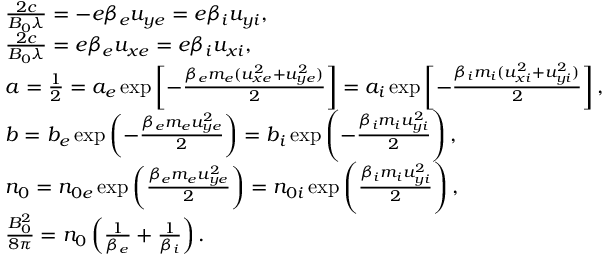Convert formula to latex. <formula><loc_0><loc_0><loc_500><loc_500>\begin{array} { r l } & { \frac { 2 c } { B _ { 0 } \lambda } = - e \beta _ { e } u _ { y e } = e \beta _ { i } u _ { y i } , } \\ & { \frac { 2 c } { B _ { 0 } \lambda } = e \beta _ { e } u _ { x e } = e \beta _ { i } u _ { x i } , } \\ & { a = \frac { 1 } { 2 } = a _ { e } \exp \left [ - \frac { \beta _ { e } m _ { e } ( u _ { x e } ^ { 2 } + u _ { y e } ^ { 2 } ) } { 2 } \right ] = a _ { i } \exp \left [ - \frac { \beta _ { i } m _ { i } ( u _ { x i } ^ { 2 } + u _ { y i } ^ { 2 } ) } { 2 } \right ] , } \\ & { b = b _ { e } \exp \left ( - \frac { \beta _ { e } m _ { e } u _ { y e } ^ { 2 } } { 2 } \right ) = b _ { i } \exp \left ( - \frac { \beta _ { i } m _ { i } u _ { y i } ^ { 2 } } { 2 } \right ) , } \\ & { n _ { 0 } = n _ { 0 e } \exp \left ( \frac { \beta _ { e } m _ { e } u _ { y e } ^ { 2 } } { 2 } \right ) = n _ { 0 i } \exp \left ( \frac { \beta _ { i } m _ { i } u _ { y i } ^ { 2 } } { 2 } \right ) , } \\ & { \frac { B _ { 0 } ^ { 2 } } { 8 \pi } = n _ { 0 } \left ( \frac { 1 } { \beta _ { e } } + \frac { 1 } { \beta _ { i } } \right ) . } \end{array}</formula> 